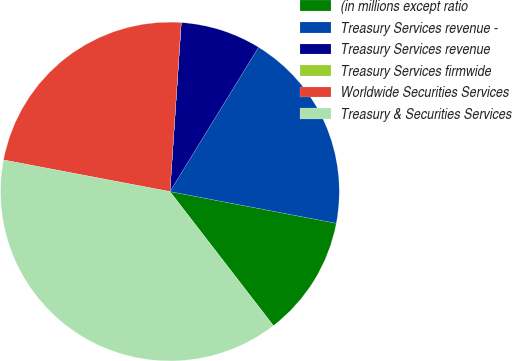<chart> <loc_0><loc_0><loc_500><loc_500><pie_chart><fcel>(in millions except ratio<fcel>Treasury Services revenue -<fcel>Treasury Services revenue<fcel>Treasury Services firmwide<fcel>Worldwide Securities Services<fcel>Treasury & Securities Services<nl><fcel>11.54%<fcel>19.23%<fcel>7.7%<fcel>0.01%<fcel>23.07%<fcel>38.45%<nl></chart> 